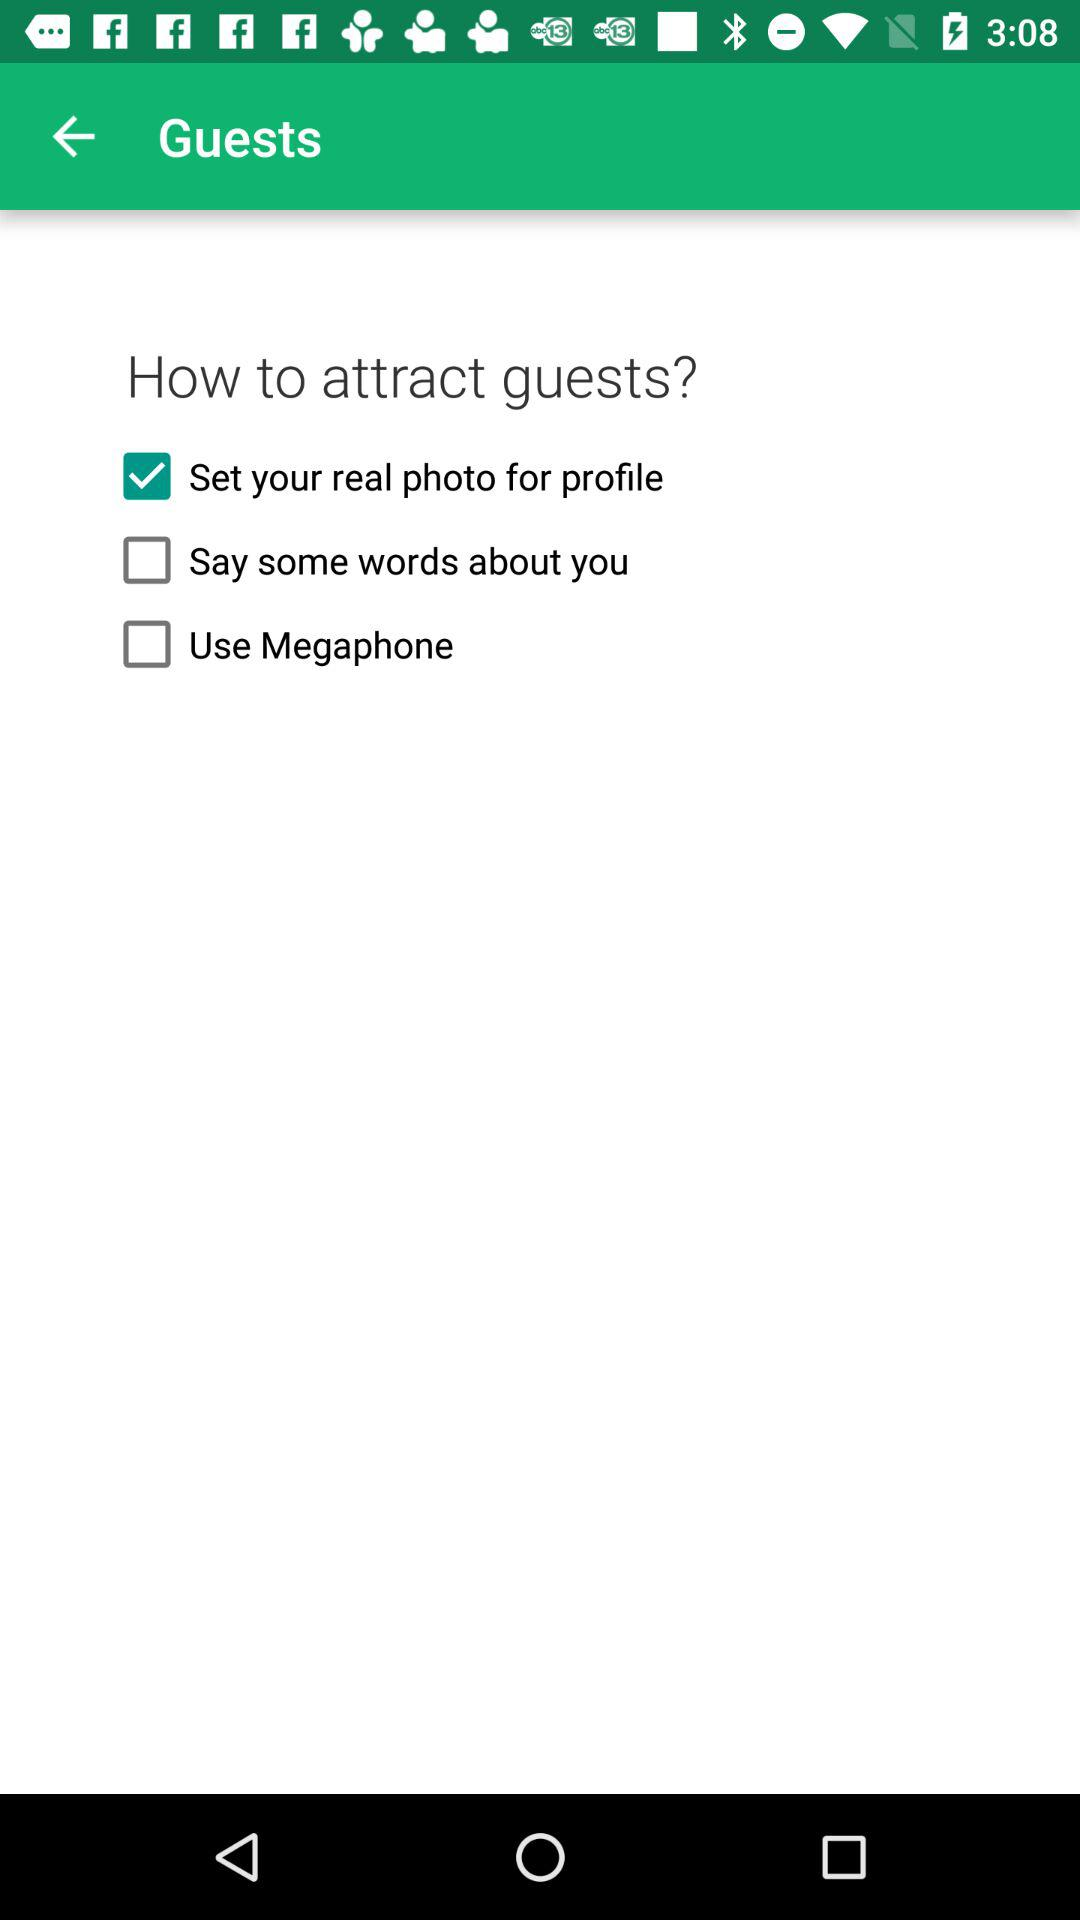What is the selected option for attracting guests? The selected option for attracting guests is "Set your real photo for profile". 